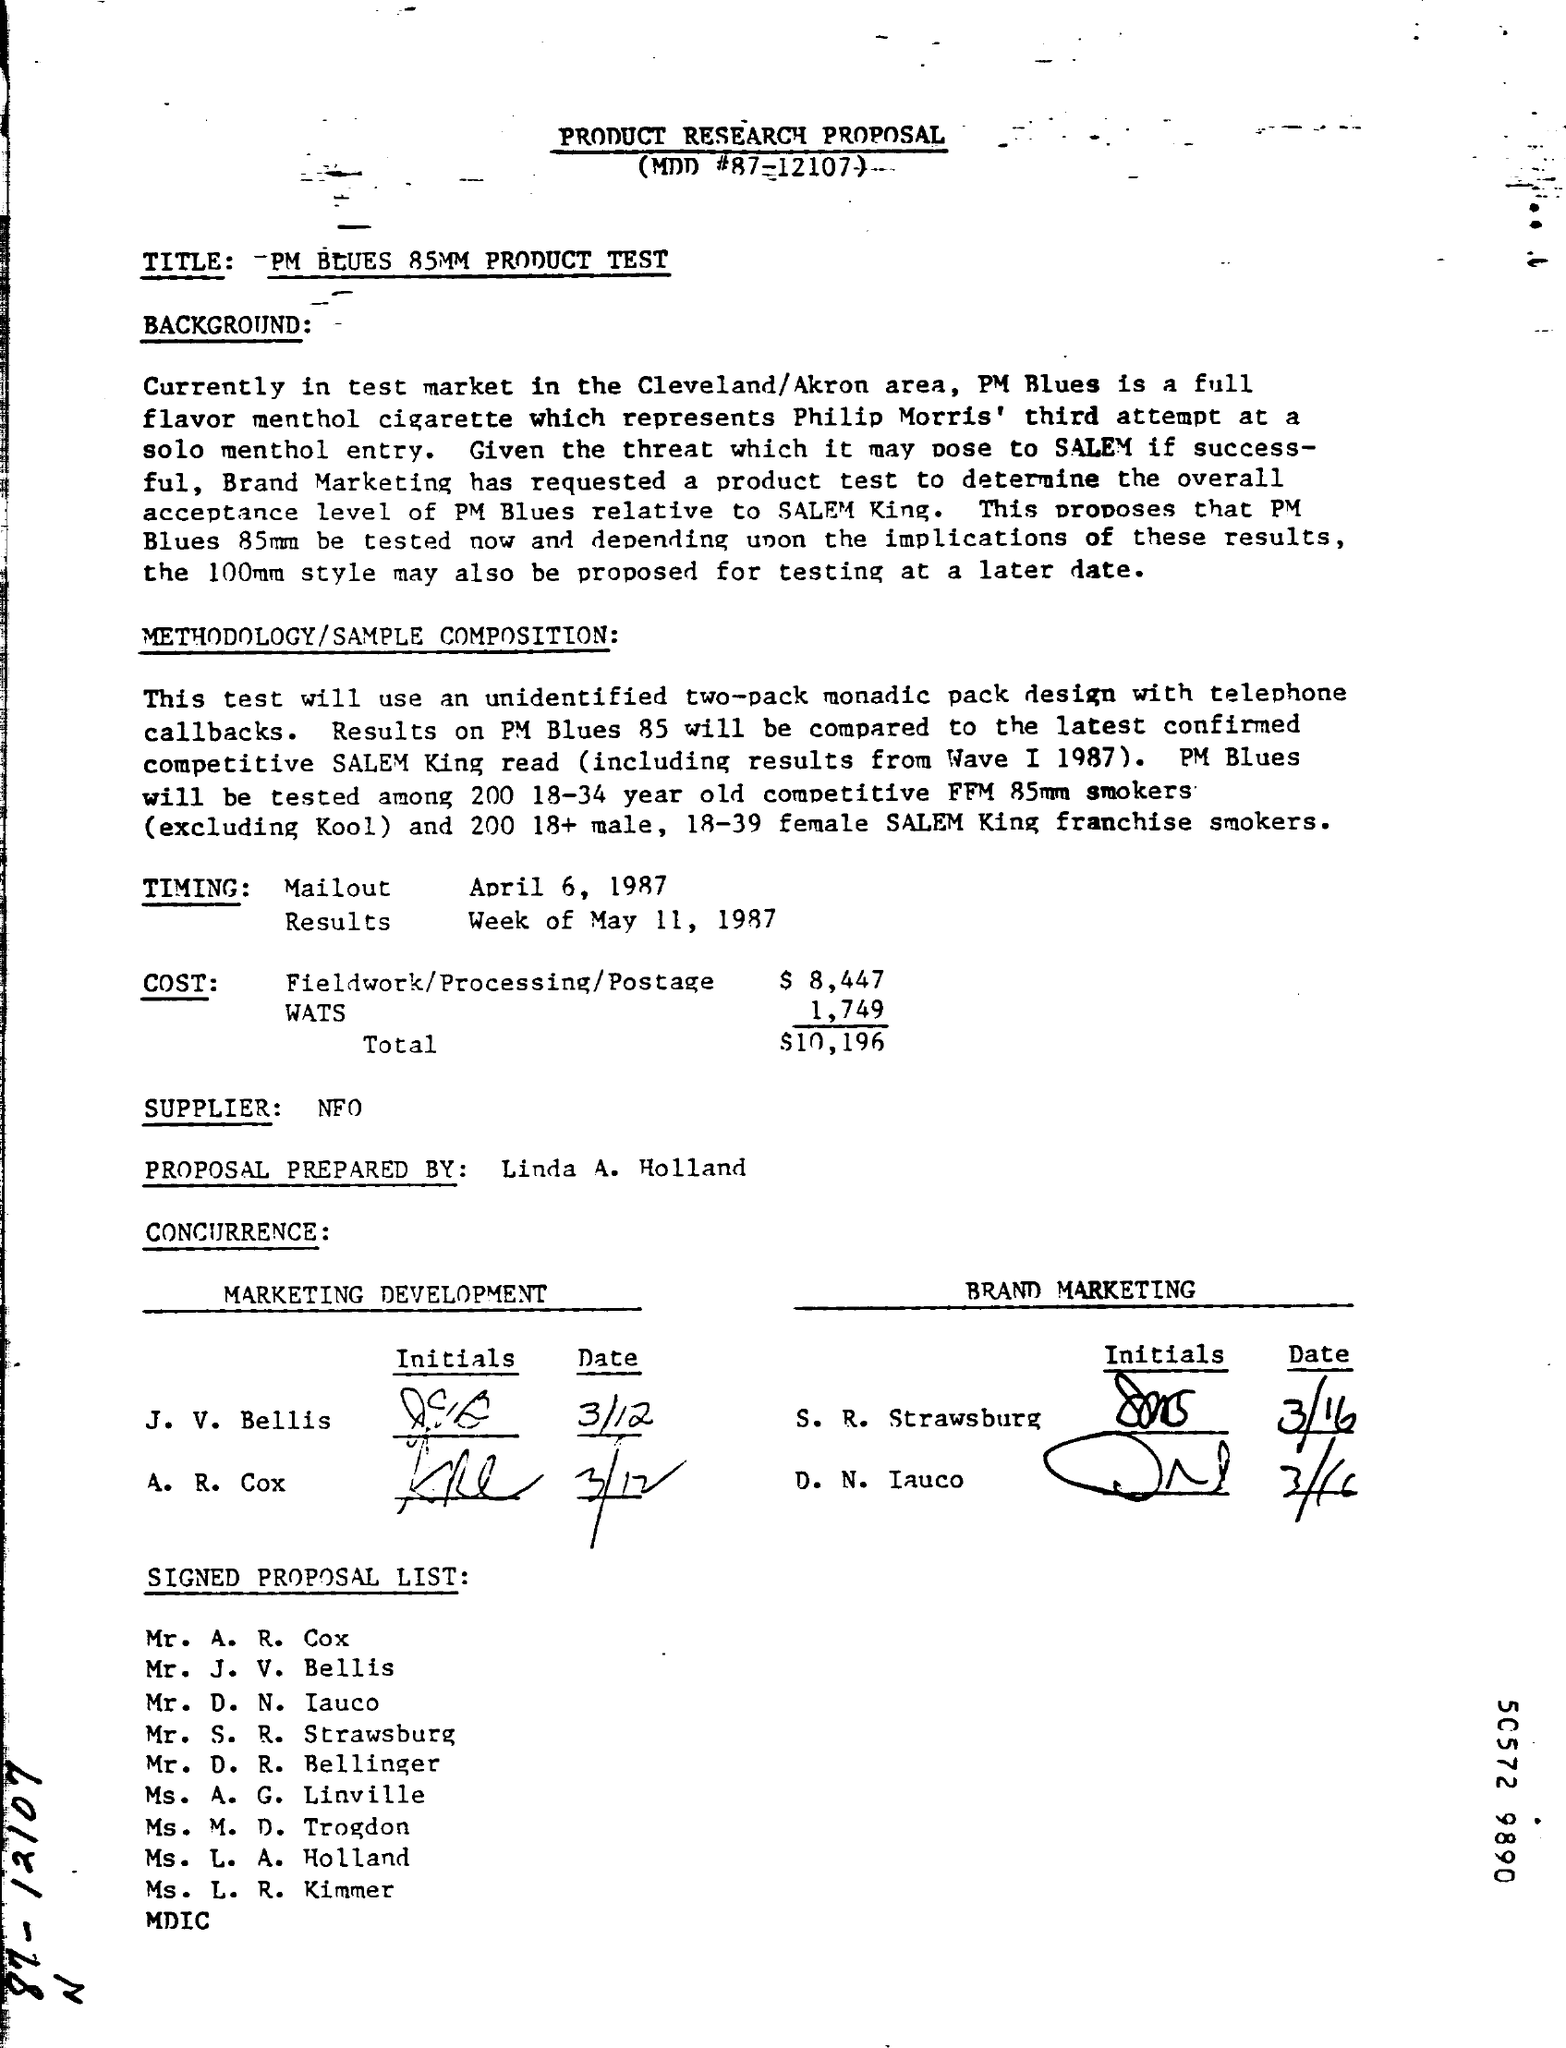Who is the supplier as mentioned in the given proposal ?
Your response must be concise. NFO. What is the total cost as mentioned in the given proposal ?
Provide a succinct answer. $ 10,196. What is the timing of mailout as mentioned in the given proposal ?
Provide a short and direct response. April 6, 1987. What is the timing of results as mentioned in the given proposal ?
Your answer should be compact. Week of may 11, 1987. What is the cost of fieldwork/processing/postage given in the proposal ?
Ensure brevity in your answer.  $ 8,447. 